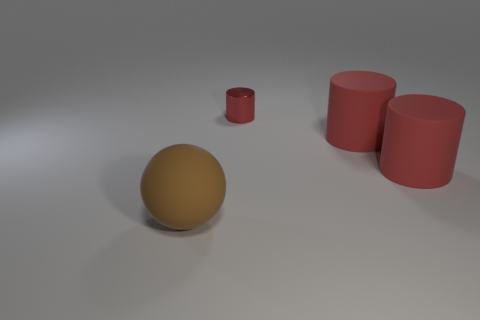Subtract all rubber cylinders. How many cylinders are left? 1 Add 4 spheres. How many objects exist? 8 Subtract 1 cylinders. How many cylinders are left? 2 Subtract all red cylinders. How many yellow balls are left? 0 Subtract all small red things. Subtract all large spheres. How many objects are left? 2 Add 4 big objects. How many big objects are left? 7 Add 4 rubber objects. How many rubber objects exist? 7 Subtract 0 cyan cubes. How many objects are left? 4 Subtract all cylinders. How many objects are left? 1 Subtract all brown cylinders. Subtract all blue cubes. How many cylinders are left? 3 